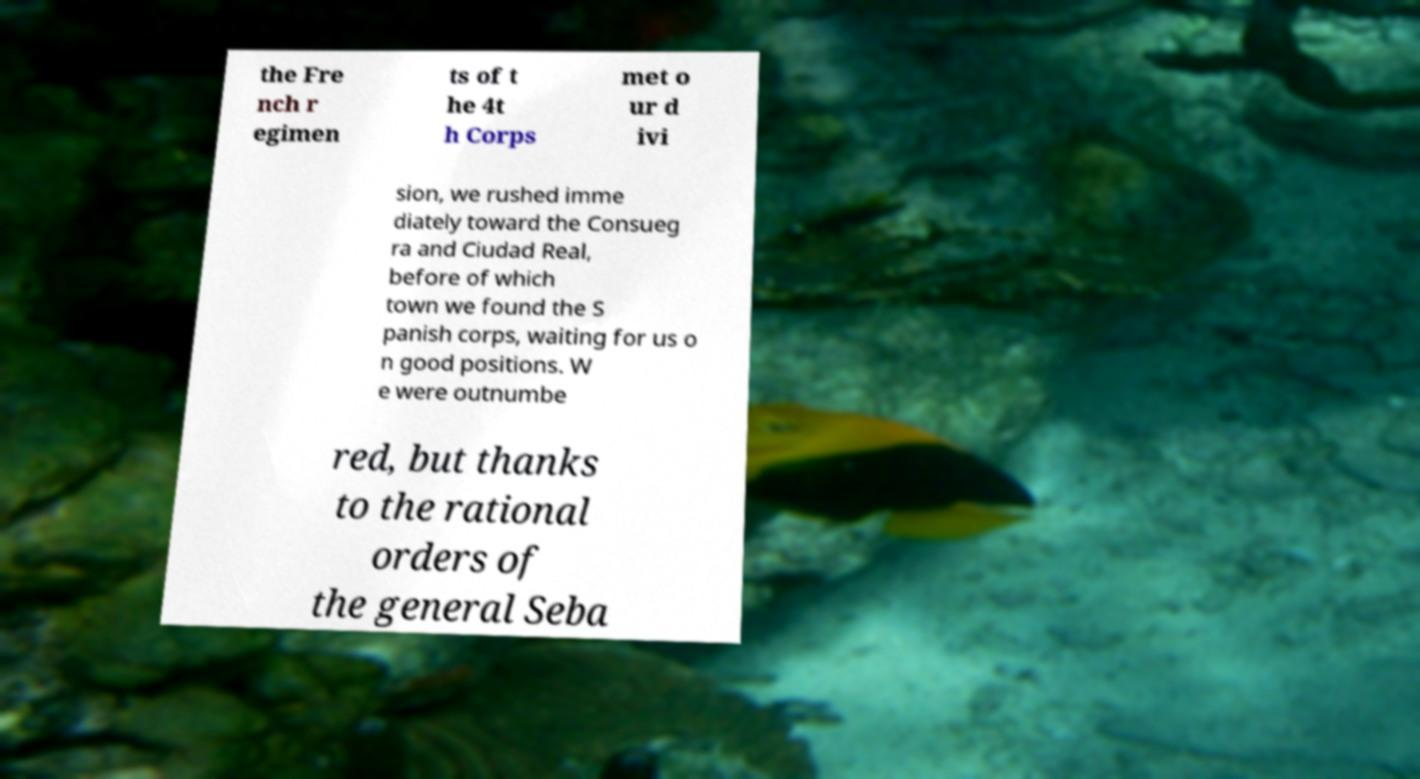I need the written content from this picture converted into text. Can you do that? the Fre nch r egimen ts of t he 4t h Corps met o ur d ivi sion, we rushed imme diately toward the Consueg ra and Ciudad Real, before of which town we found the S panish corps, waiting for us o n good positions. W e were outnumbe red, but thanks to the rational orders of the general Seba 